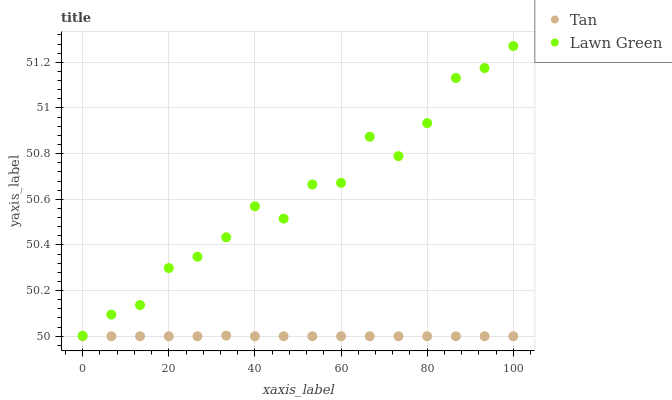Does Tan have the minimum area under the curve?
Answer yes or no. Yes. Does Lawn Green have the maximum area under the curve?
Answer yes or no. Yes. Does Tan have the maximum area under the curve?
Answer yes or no. No. Is Tan the smoothest?
Answer yes or no. Yes. Is Lawn Green the roughest?
Answer yes or no. Yes. Is Tan the roughest?
Answer yes or no. No. Does Tan have the lowest value?
Answer yes or no. Yes. Does Lawn Green have the highest value?
Answer yes or no. Yes. Does Tan have the highest value?
Answer yes or no. No. Is Tan less than Lawn Green?
Answer yes or no. Yes. Is Lawn Green greater than Tan?
Answer yes or no. Yes. Does Tan intersect Lawn Green?
Answer yes or no. No. 